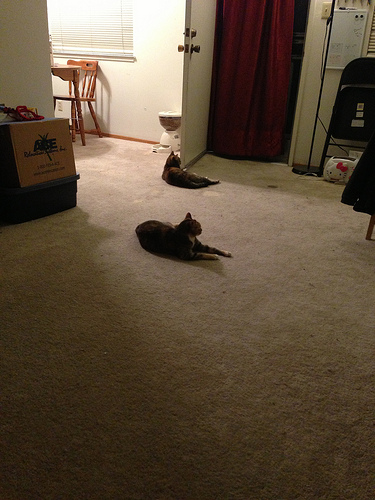<image>
Is the cat on the table? No. The cat is not positioned on the table. They may be near each other, but the cat is not supported by or resting on top of the table. 